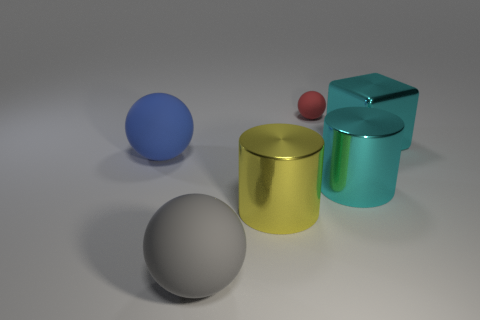Add 2 large blue rubber things. How many objects exist? 8 Subtract all cubes. How many objects are left? 5 Subtract 1 gray spheres. How many objects are left? 5 Subtract all small red things. Subtract all tiny brown metallic cubes. How many objects are left? 5 Add 3 tiny matte spheres. How many tiny matte spheres are left? 4 Add 6 large cyan cylinders. How many large cyan cylinders exist? 7 